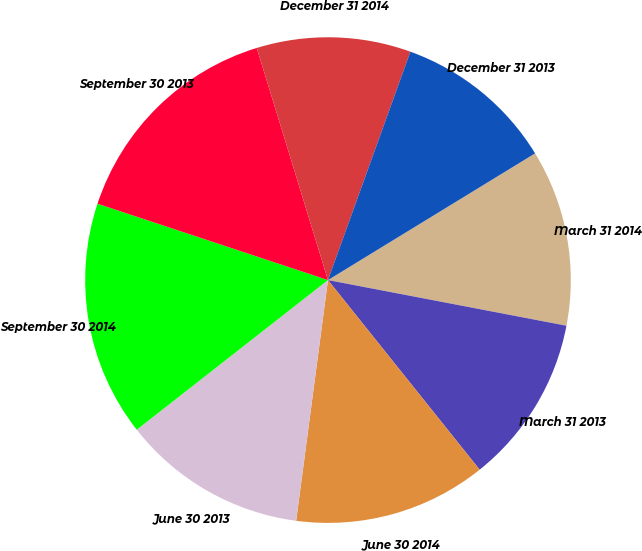Convert chart. <chart><loc_0><loc_0><loc_500><loc_500><pie_chart><fcel>March 31 2014<fcel>March 31 2013<fcel>June 30 2014<fcel>June 30 2013<fcel>September 30 2014<fcel>September 30 2013<fcel>December 31 2014<fcel>December 31 2013<nl><fcel>11.75%<fcel>11.25%<fcel>12.83%<fcel>12.34%<fcel>15.66%<fcel>15.17%<fcel>10.25%<fcel>10.75%<nl></chart> 